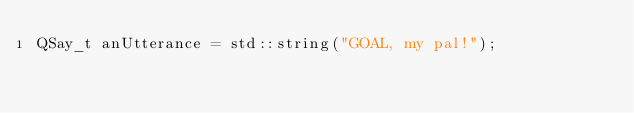Convert code to text. <code><loc_0><loc_0><loc_500><loc_500><_ObjectiveC_>QSay_t anUtterance = std::string("GOAL, my pal!");
</code> 